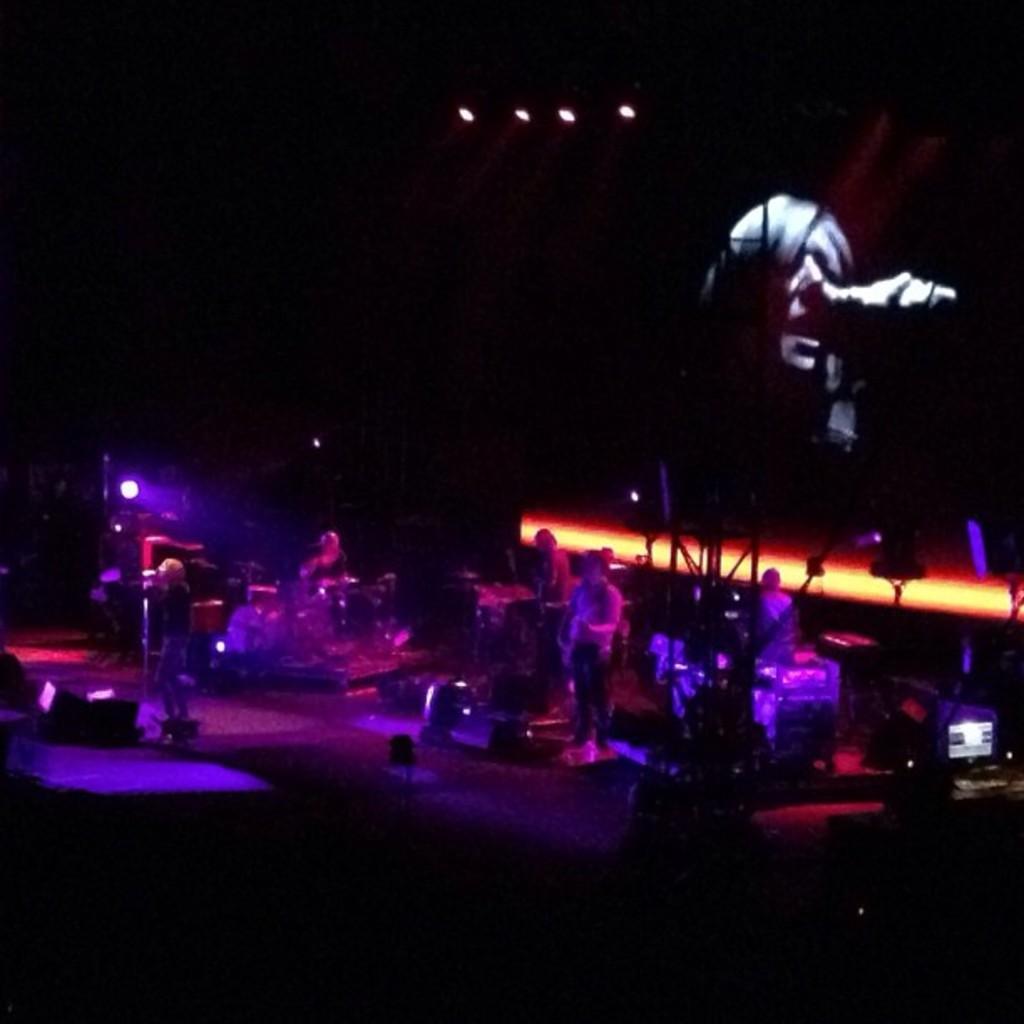Please provide a concise description of this image. There is a stage. On the stage there are many people. Also there are musical instruments. Also there is a screen with persons face. Also there are lights. And the image is looking dark. 